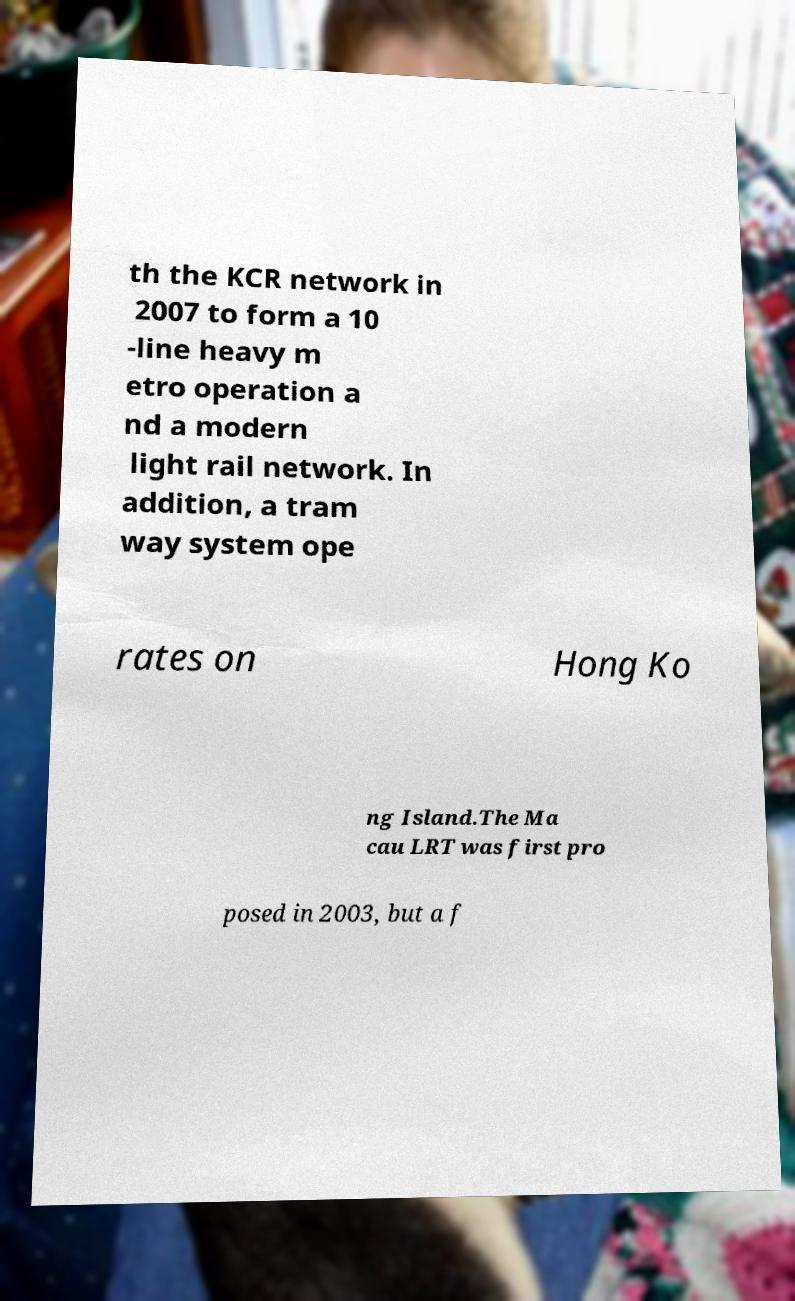Please identify and transcribe the text found in this image. th the KCR network in 2007 to form a 10 -line heavy m etro operation a nd a modern light rail network. In addition, a tram way system ope rates on Hong Ko ng Island.The Ma cau LRT was first pro posed in 2003, but a f 